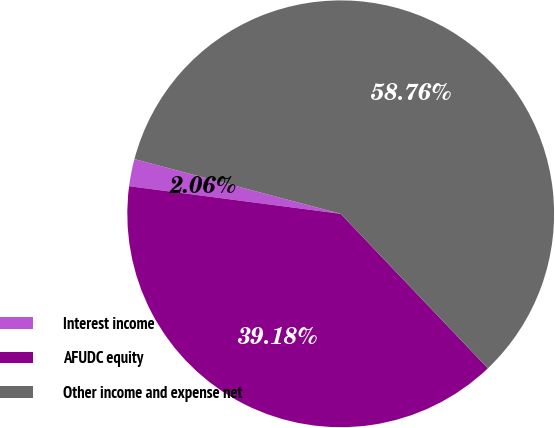Convert chart to OTSL. <chart><loc_0><loc_0><loc_500><loc_500><pie_chart><fcel>Interest income<fcel>AFUDC equity<fcel>Other income and expense net<nl><fcel>2.06%<fcel>39.18%<fcel>58.76%<nl></chart> 